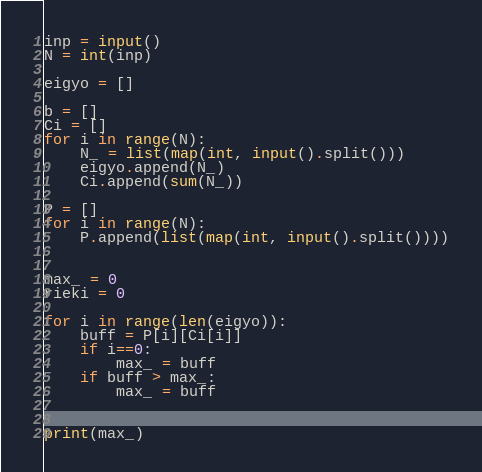Convert code to text. <code><loc_0><loc_0><loc_500><loc_500><_Python_>inp = input()
N = int(inp)

eigyo = []

b = []
Ci = []
for i in range(N):
    N_ = list(map(int, input().split()))
    eigyo.append(N_)
    Ci.append(sum(N_))

P = []
for i in range(N):
    P.append(list(map(int, input().split())))


max_ = 0
rieki = 0

for i in range(len(eigyo)):
    buff = P[i][Ci[i]]
    if i==0:
        max_ = buff
    if buff > max_:
        max_ = buff
    

print(max_)
</code> 